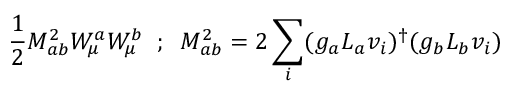Convert formula to latex. <formula><loc_0><loc_0><loc_500><loc_500>\frac { 1 } { 2 } M _ { a b } ^ { 2 } W _ { \mu } ^ { a } W _ { \mu } ^ { b } \, ; \, M _ { a b } ^ { 2 } = 2 \sum _ { i } ( g _ { a } L _ { a } v _ { i } ) ^ { \dagger } ( g _ { b } L _ { b } v _ { i } )</formula> 